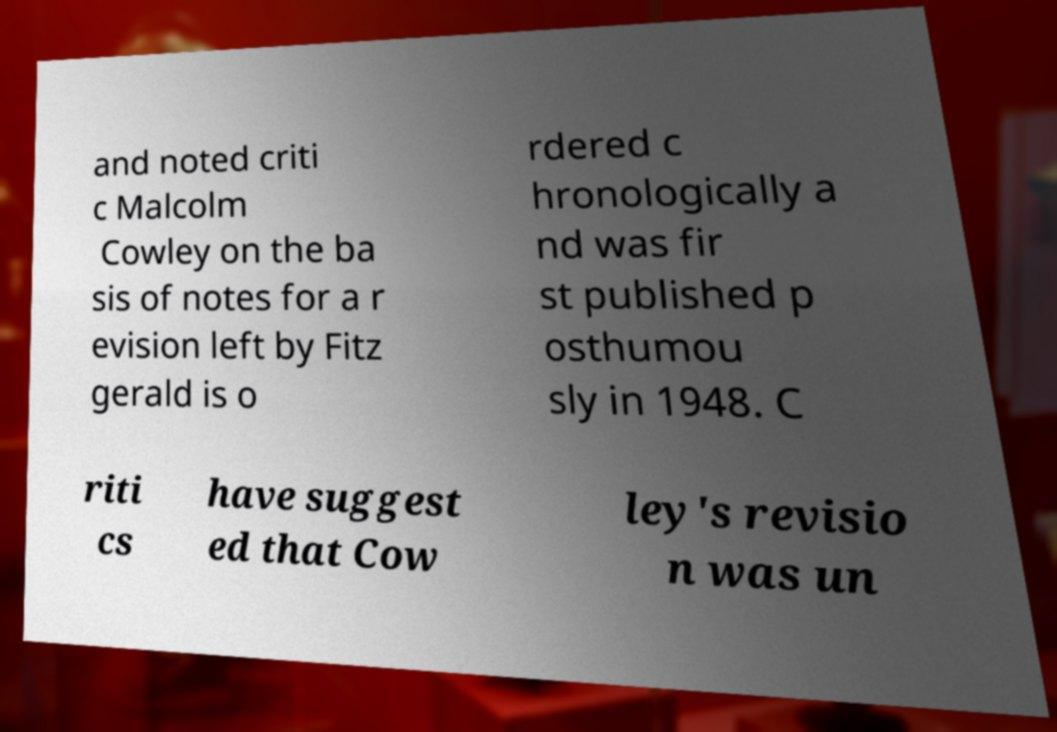Please read and relay the text visible in this image. What does it say? and noted criti c Malcolm Cowley on the ba sis of notes for a r evision left by Fitz gerald is o rdered c hronologically a nd was fir st published p osthumou sly in 1948. C riti cs have suggest ed that Cow ley's revisio n was un 